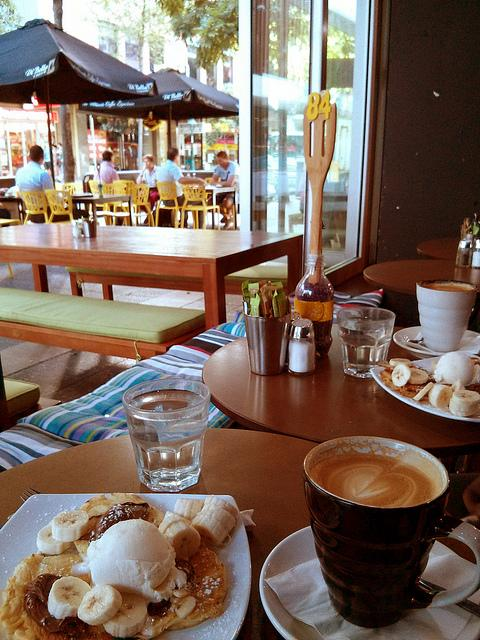What does the number 84 represent? table number 